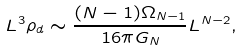Convert formula to latex. <formula><loc_0><loc_0><loc_500><loc_500>L ^ { 3 } \rho _ { d } \sim \frac { ( N - 1 ) \Omega _ { N - 1 } } { 1 6 \pi G _ { N } } L ^ { N - 2 } ,</formula> 